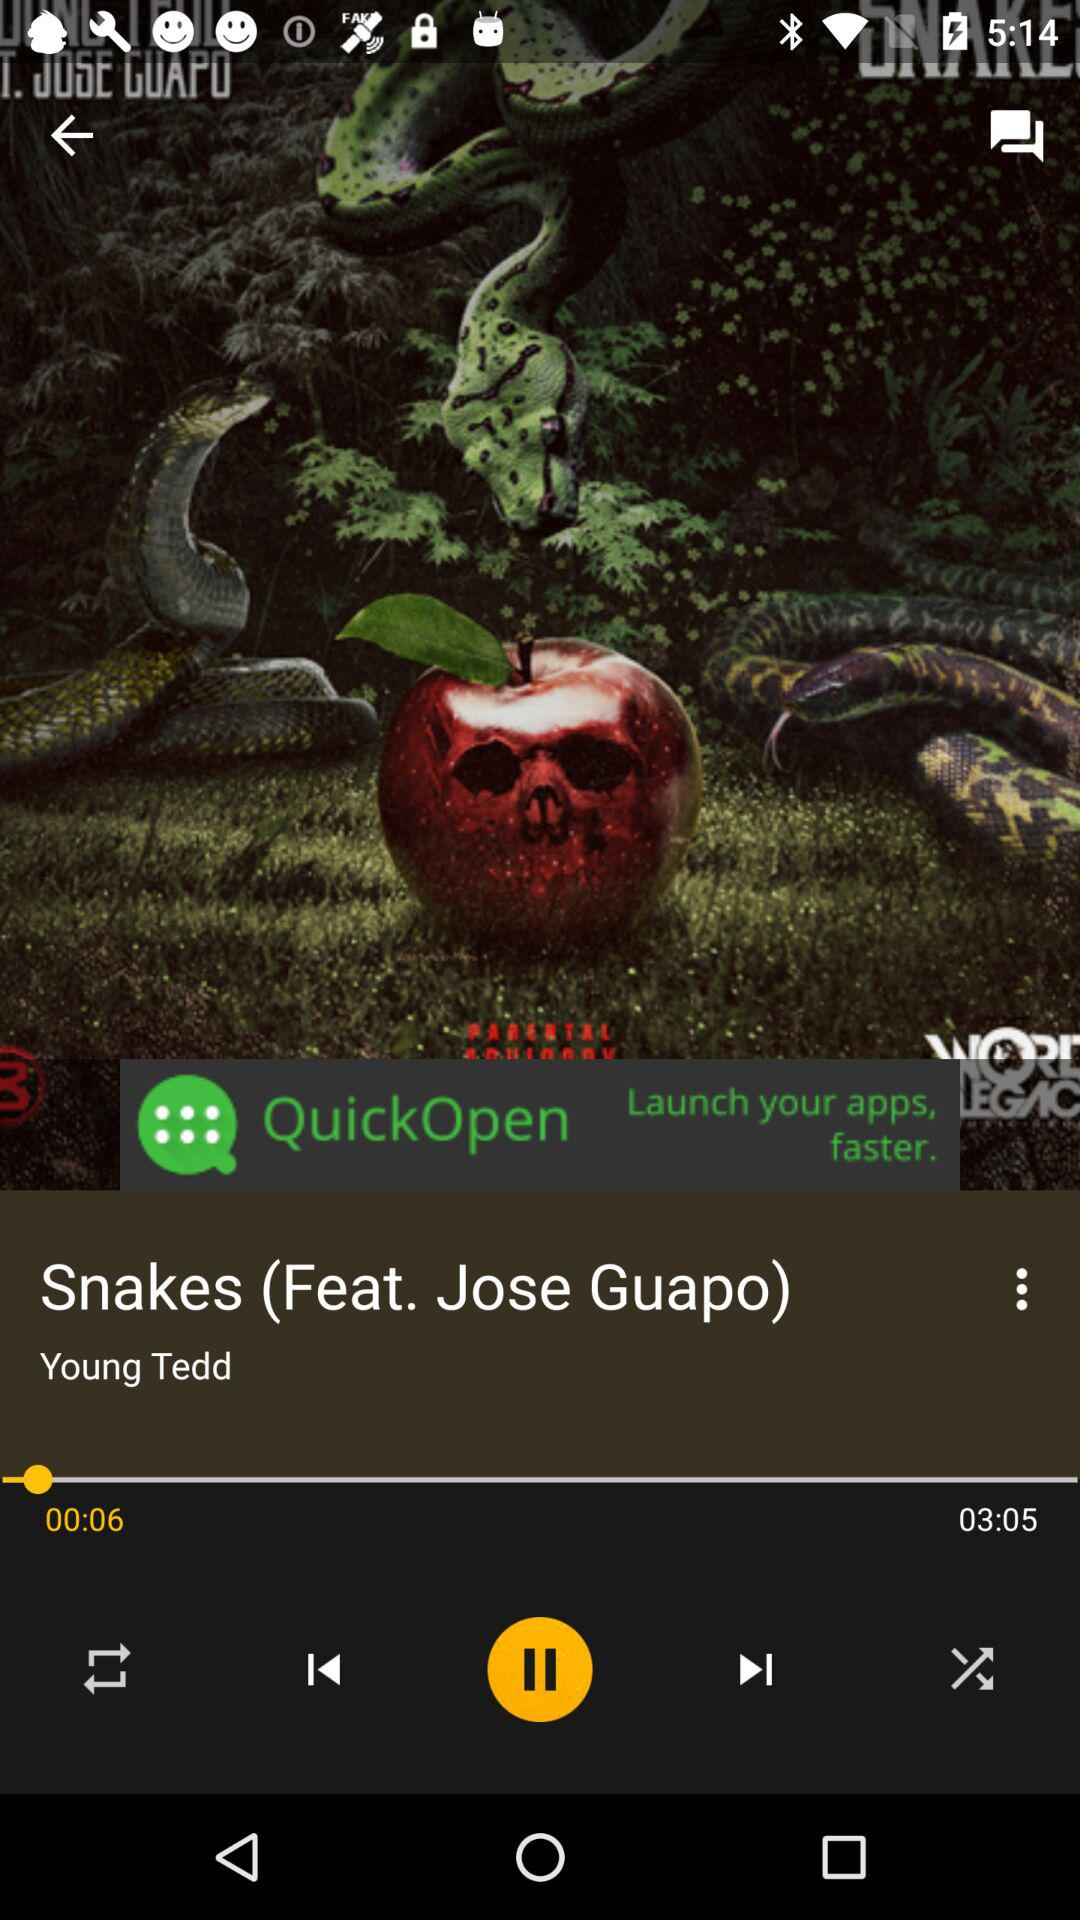For how long has the song been played? The song has been played for 6 seconds. 